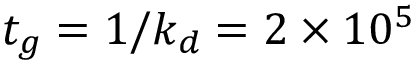Convert formula to latex. <formula><loc_0><loc_0><loc_500><loc_500>t _ { g } = 1 / k _ { d } = 2 \times 1 0 ^ { 5 }</formula> 